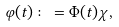<formula> <loc_0><loc_0><loc_500><loc_500>\varphi ( t ) \colon = \Phi ( t ) \chi ,</formula> 